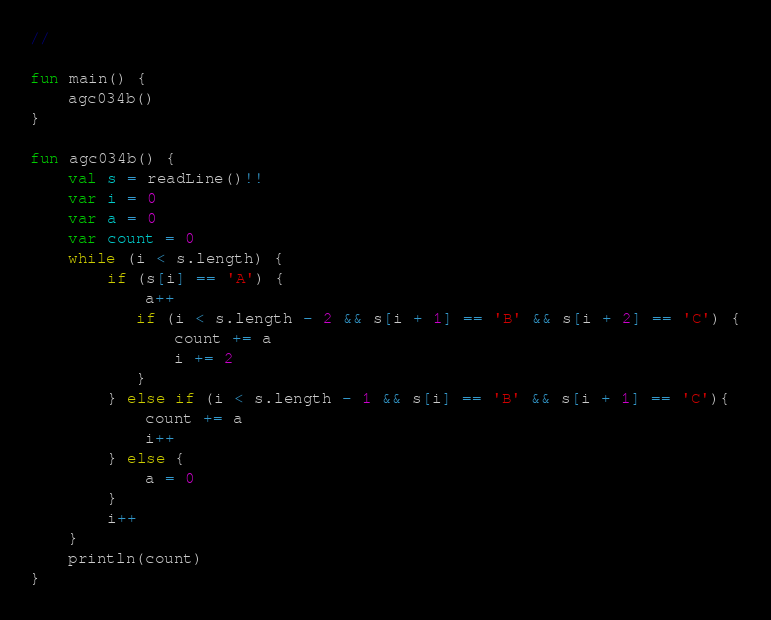<code> <loc_0><loc_0><loc_500><loc_500><_Kotlin_>//

fun main() {
    agc034b()
}

fun agc034b() {
    val s = readLine()!!
    var i = 0
    var a = 0
    var count = 0
    while (i < s.length) {
        if (s[i] == 'A') {
            a++
           if (i < s.length - 2 && s[i + 1] == 'B' && s[i + 2] == 'C') {
               count += a
               i += 2
           }
        } else if (i < s.length - 1 && s[i] == 'B' && s[i + 1] == 'C'){
            count += a
            i++
        } else {
            a = 0
        }
        i++
    }
    println(count)
}</code> 